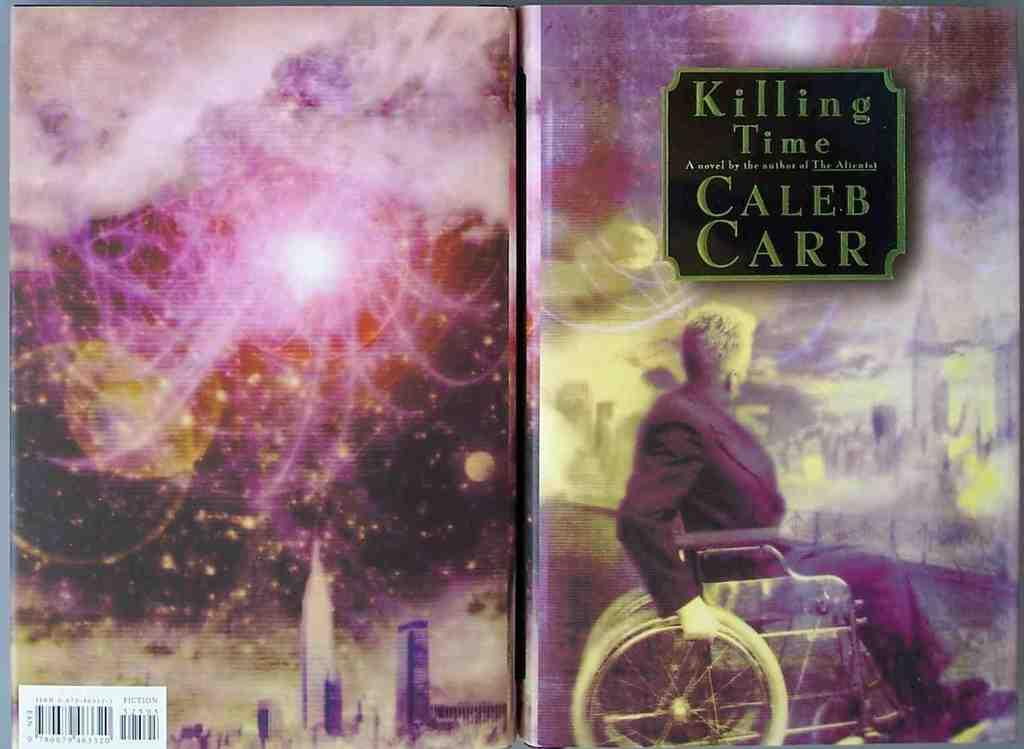Provide a one-sentence caption for the provided image. The front and back cover of a book called Killing Time shows a man in a wheelchair. 